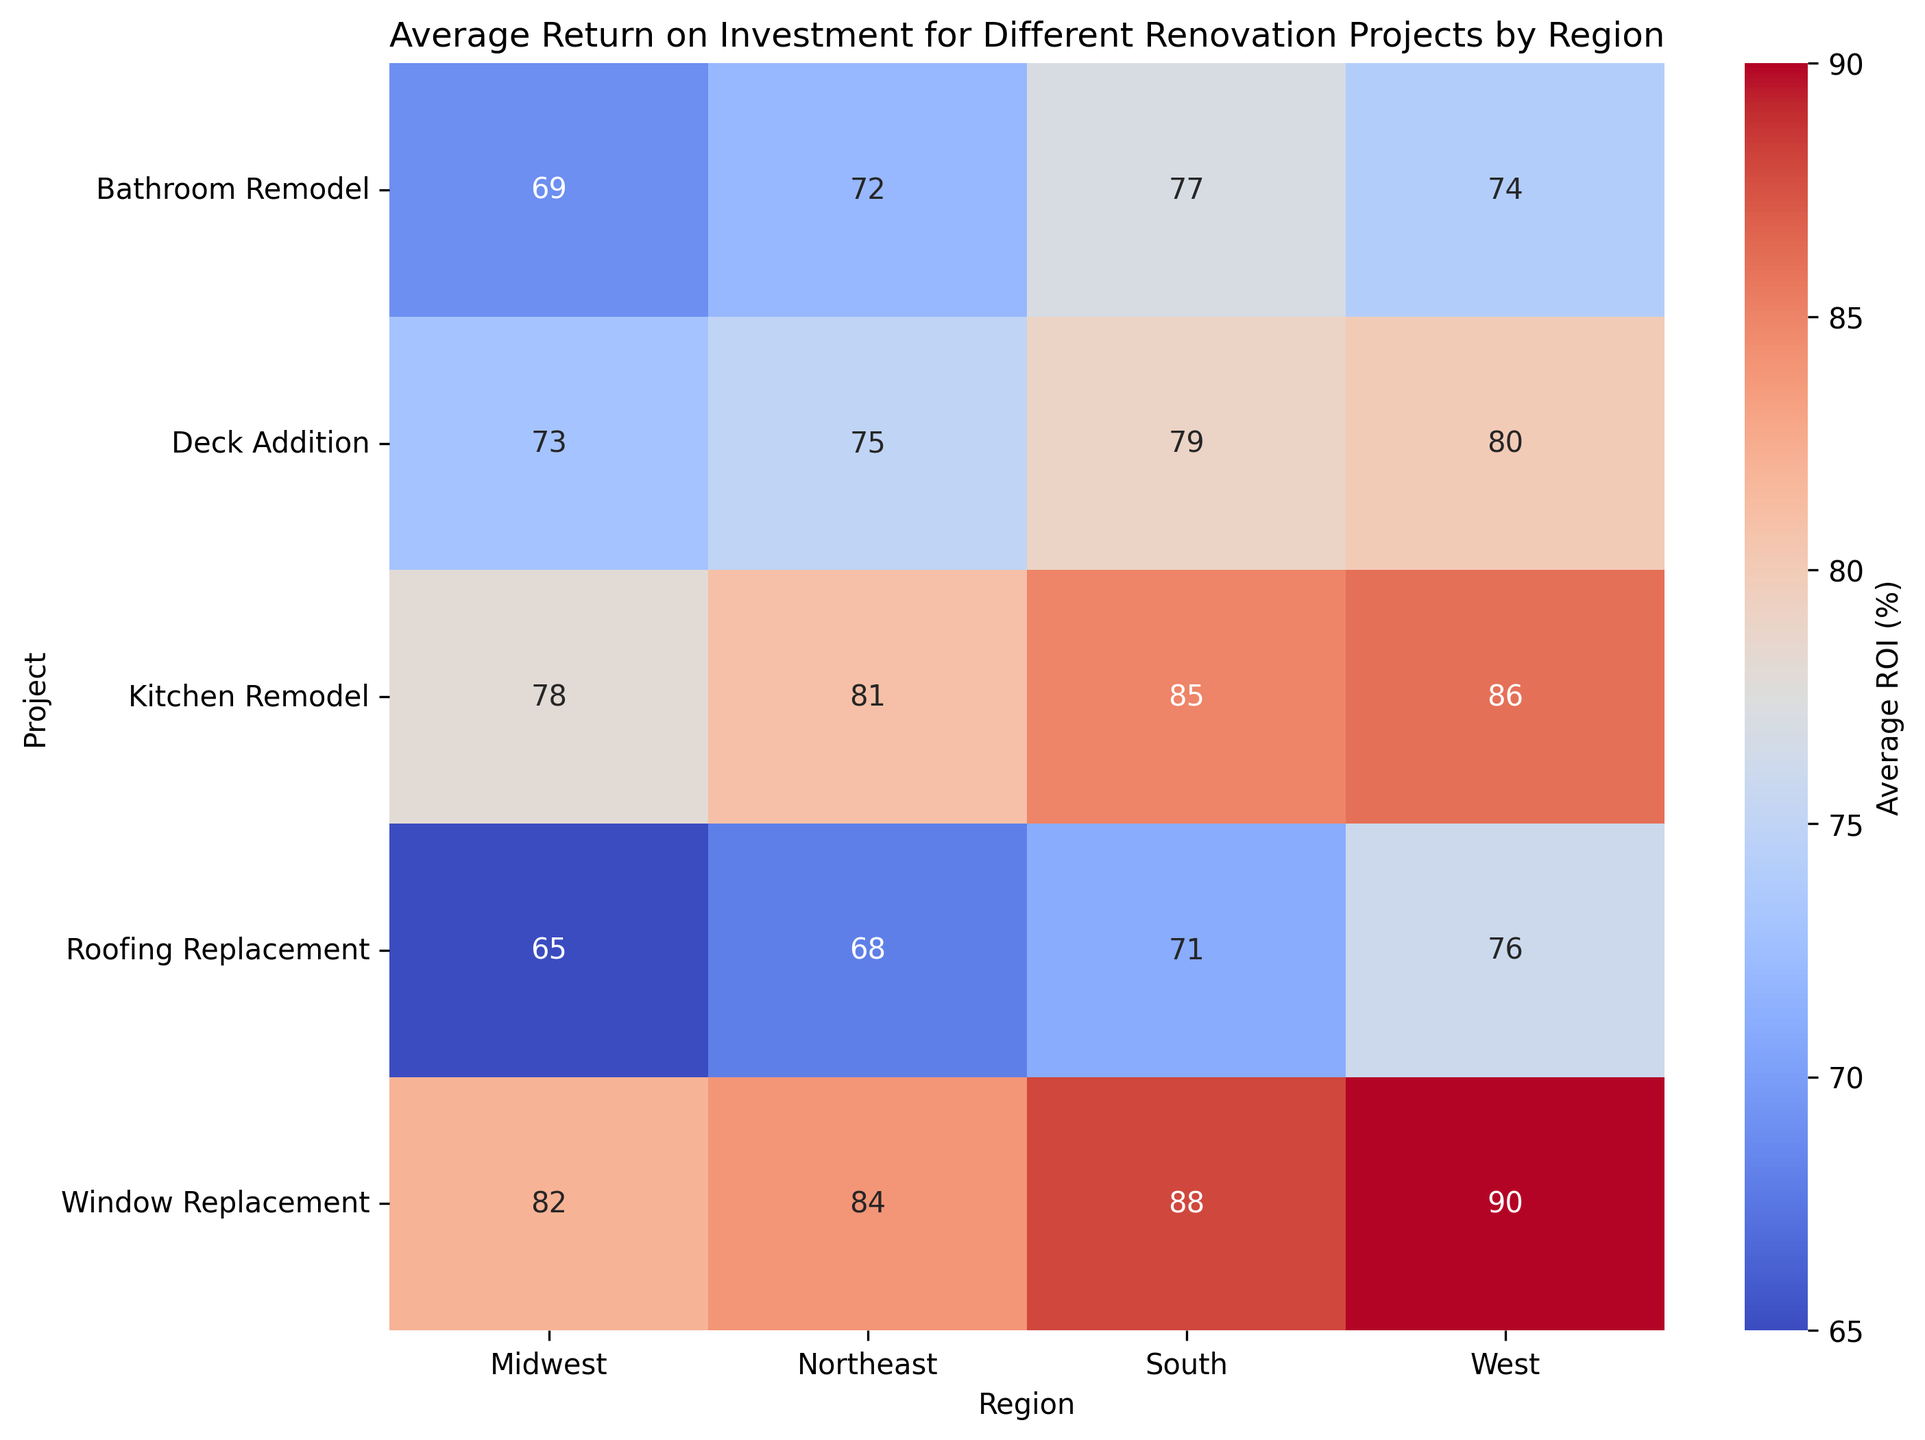What region has the highest average ROI for a Kitchen Remodel? By looking at the heatmap, you can see that the West region has the highest average ROI for a Kitchen Remodel, which is marked with a value of 86.
Answer: West Compare the average ROI for Bathroom Remodel and Deck Addition in the Northeast. Which project has a higher ROI? The heatmap shows the average ROI for Bathroom Remodel as 72 and for Deck Addition as 75 in the Northeast. Deck Addition has a higher ROI than Bathroom Remodel.
Answer: Deck Addition Which region shows the most significant difference between the average ROIs of a Kitchen Remodel and a Window Replacement? By examining the differences in values for Kitchen Remodel and Window Replacement in each region: Northeast (81 vs. 84), Midwest (78 vs. 82), South (85 vs. 88), West (86 vs. 90), the West has the largest difference of 4 percentage points (90 - 86).
Answer: West What is the combined average ROI of Bathroom Remodel in all four regions? Add the average ROIs of Bathroom Remodel for all regions: Northeast (72) + Midwest (69) + South (77) + West (74) = 292 and then divide by 4 to get the average: 73.
Answer: 73 For the project with the lowest average ROI in the Midwest, what is this value and what project is it? In the Midwest region, the heatmap indicates that the Roofing Replacement project has the lowest average ROI at 65.
Answer: Roofing Replacement, 65 In which region does the Deck Addition have the third highest average ROI compared to other projects in that region? For each region, compare the ROIs:
Northeast: Deck Addition (75) is the third highest after Window Replacement (84) and Kitchen Remodel (81).
Midwest: Deck Addition (73) is the third highest after Window Replacement (82) and Kitchen Remodel (78).
South: Deck Addition (79) is the third highest after Window Replacement (88) and Kitchen Remodel (85).
West: Deck Addition (80) is the third highest after Window Replacement (90) and Kitchen Remodel (86).
Thus, the Deck Addition in every region has the third highest ROI compared to other projects in the same region.
Answer: All regions Is there any region where a Bathroom Remodel has an average ROI higher than 75? The heatmap shows that the South region has a Bathroom Remodel average ROI of 77, which is higher than 75.
Answer: South Which project in the West region has the second highest average ROI? In the West region, the heatmap indicates:
Kitchen Remodel (86), Bathroom Remodel (74), Deck Addition (80), Window Replacement (90), and Roofing Replacement (76).
The project with the second highest ROI is the Kitchen Remodel at 86 (after Window Replacement at 90).
Answer: Kitchen Remodel Identify the regions where Window Replacement has the highest average ROI among other projects in the same region. By comparing the ROIs within each region:
Northeast: Window Replacement (84) is the highest.
Midwest: Window Replacement (82) is the highest.
South: Window Replacement (88) is the highest.
West: Window Replacement (90) is the highest.
Therefore, in all regions, Window Replacement has the highest average ROI.
Answer: All regions What is the average ROI for Roofing Replacement across all regions? Add the average ROIs for Roofing Replacement in each region: Northeast (68) + Midwest (65) + South (71) + West (76) = 280. Divide by 4 to find the average: 280/4 = 70.
Answer: 70 